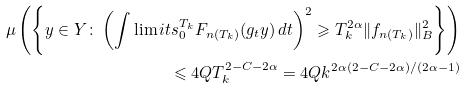<formula> <loc_0><loc_0><loc_500><loc_500>\mu \left ( \left \{ y \in Y \colon \left ( \int \lim i t s _ { 0 } ^ { T _ { k } } F _ { n ( T _ { k } ) } ( g _ { t } y ) \, d t \right ) ^ { 2 } \geqslant T _ { k } ^ { 2 \alpha } \| f _ { n ( T _ { k } ) } \| _ { B } ^ { 2 } \right \} \right ) \\ \leqslant 4 Q T _ { k } ^ { 2 - C - 2 \alpha } = 4 Q k ^ { 2 \alpha ( 2 - C - 2 \alpha ) / ( 2 \alpha - 1 ) }</formula> 